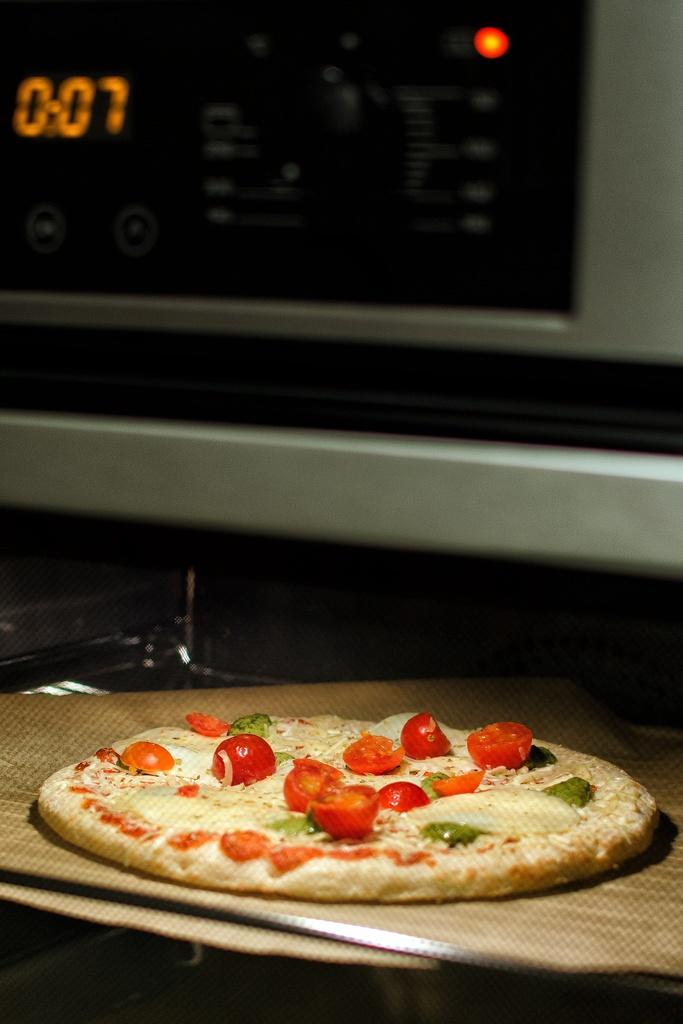How many seconds are left on the microwave oven?
Give a very brief answer. 7. 